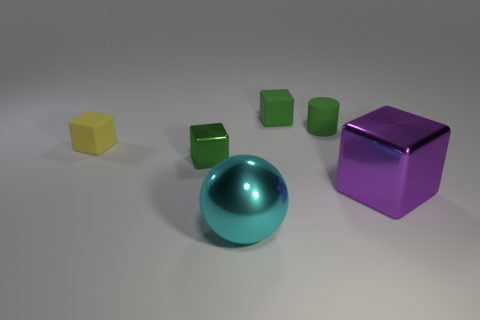How many matte blocks are the same color as the small shiny block?
Provide a succinct answer. 1. The purple thing to the right of the green cube to the right of the shiny object that is in front of the purple object is made of what material?
Keep it short and to the point. Metal. What number of red objects are small matte objects or small things?
Provide a short and direct response. 0. What is the size of the metallic block that is on the left side of the metallic cube in front of the small green cube that is left of the shiny sphere?
Your response must be concise. Small. The yellow matte thing that is the same shape as the big purple object is what size?
Offer a terse response. Small. How many big objects are either green rubber cubes or green rubber cylinders?
Ensure brevity in your answer.  0. Is the material of the tiny green cube that is to the left of the ball the same as the green object that is behind the tiny cylinder?
Your answer should be very brief. No. There is a big thing that is on the left side of the small green matte cylinder; what is it made of?
Your answer should be very brief. Metal. How many metallic things are large things or green cubes?
Give a very brief answer. 3. What color is the matte block that is to the left of the tiny cube that is to the right of the big metal sphere?
Your response must be concise. Yellow. 